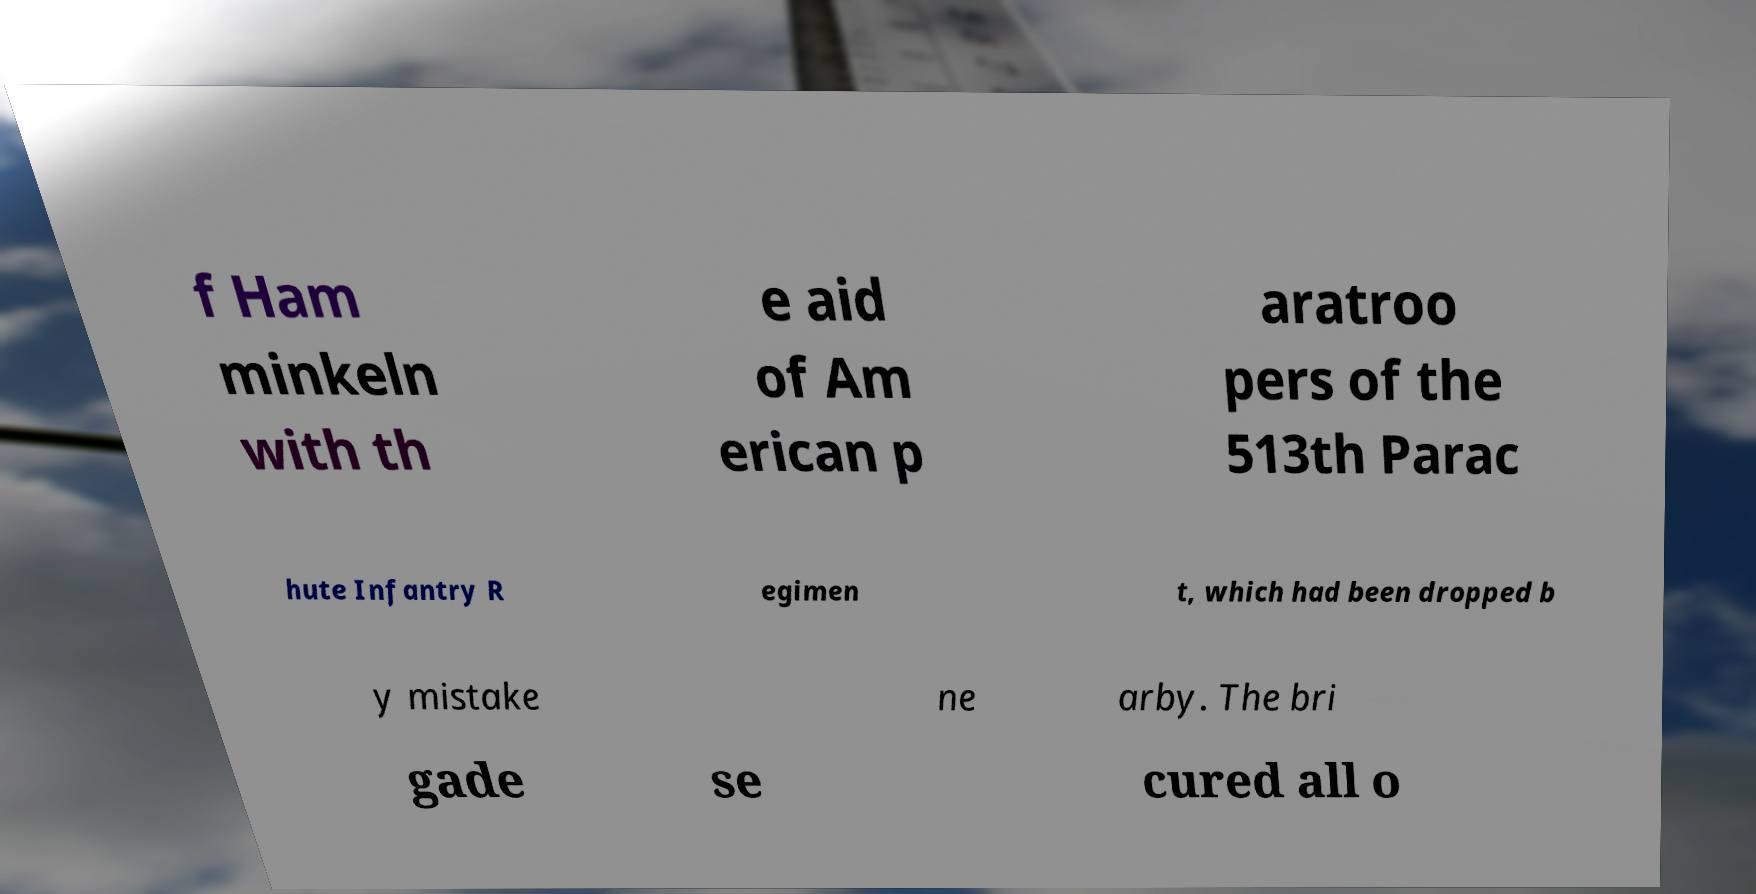Could you extract and type out the text from this image? f Ham minkeln with th e aid of Am erican p aratroo pers of the 513th Parac hute Infantry R egimen t, which had been dropped b y mistake ne arby. The bri gade se cured all o 